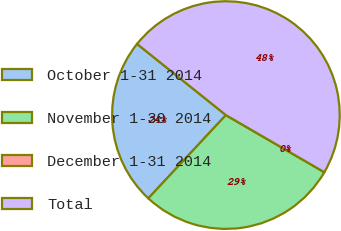Convert chart. <chart><loc_0><loc_0><loc_500><loc_500><pie_chart><fcel>October 1-31 2014<fcel>November 1-30 2014<fcel>December 1-31 2014<fcel>Total<nl><fcel>23.81%<fcel>28.57%<fcel>0.0%<fcel>47.62%<nl></chart> 